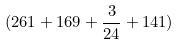Convert formula to latex. <formula><loc_0><loc_0><loc_500><loc_500>( 2 6 1 + 1 6 9 + \frac { 3 } { 2 4 } + 1 4 1 )</formula> 